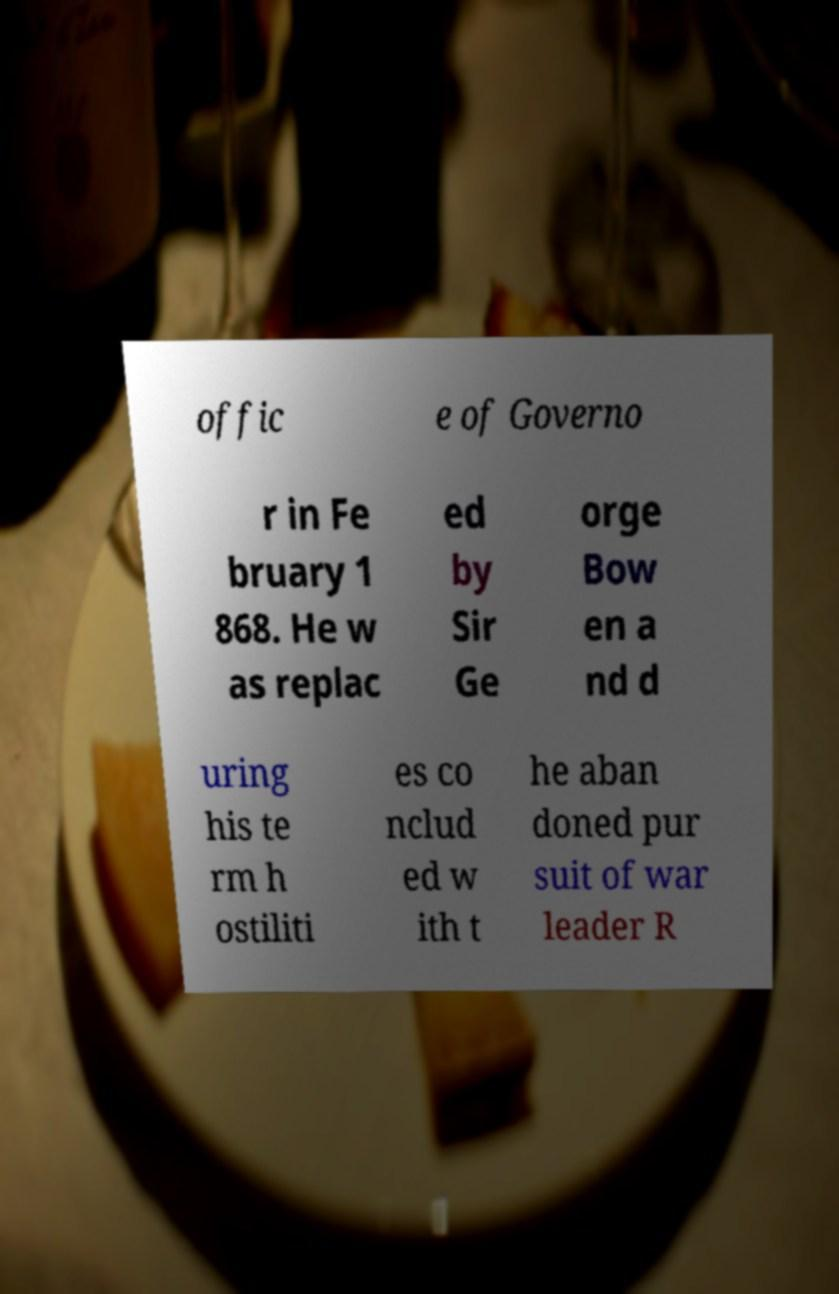Please read and relay the text visible in this image. What does it say? offic e of Governo r in Fe bruary 1 868. He w as replac ed by Sir Ge orge Bow en a nd d uring his te rm h ostiliti es co nclud ed w ith t he aban doned pur suit of war leader R 